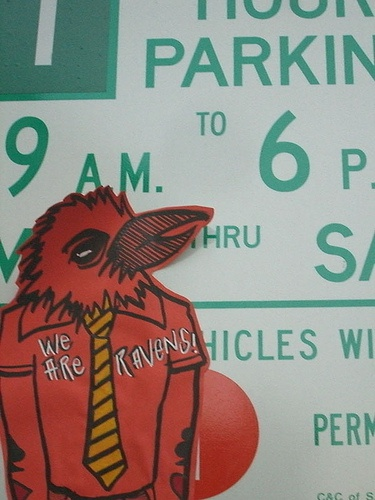Describe the objects in this image and their specific colors. I can see bird in teal, brown, maroon, and black tones and tie in teal, olive, black, and maroon tones in this image. 